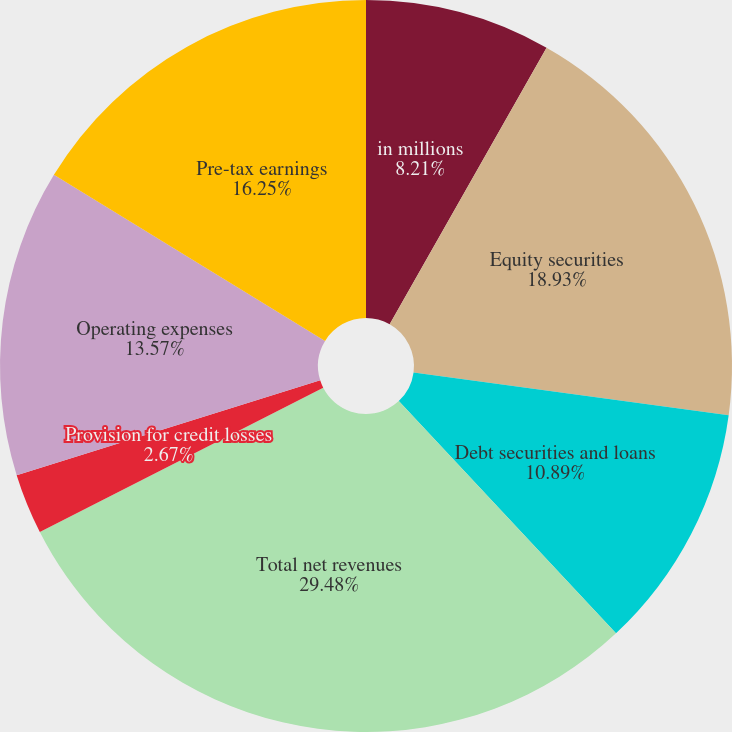Convert chart to OTSL. <chart><loc_0><loc_0><loc_500><loc_500><pie_chart><fcel>in millions<fcel>Equity securities<fcel>Debt securities and loans<fcel>Total net revenues<fcel>Provision for credit losses<fcel>Operating expenses<fcel>Pre-tax earnings<nl><fcel>8.21%<fcel>18.93%<fcel>10.89%<fcel>29.47%<fcel>2.67%<fcel>13.57%<fcel>16.25%<nl></chart> 